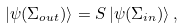Convert formula to latex. <formula><loc_0><loc_0><loc_500><loc_500>| \psi ( \Sigma _ { o u t } ) \rangle = S \, | \psi ( \Sigma _ { i n } ) \rangle \, ,</formula> 